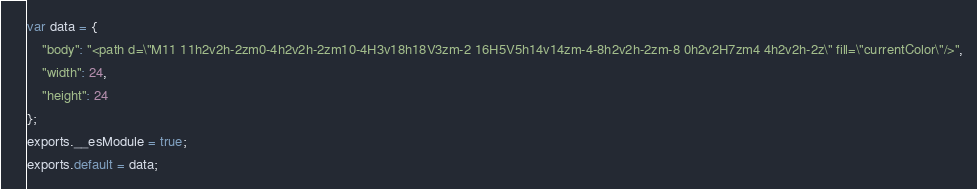<code> <loc_0><loc_0><loc_500><loc_500><_JavaScript_>var data = {
	"body": "<path d=\"M11 11h2v2h-2zm0-4h2v2h-2zm10-4H3v18h18V3zm-2 16H5V5h14v14zm-4-8h2v2h-2zm-8 0h2v2H7zm4 4h2v2h-2z\" fill=\"currentColor\"/>",
	"width": 24,
	"height": 24
};
exports.__esModule = true;
exports.default = data;
</code> 